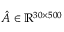Convert formula to latex. <formula><loc_0><loc_0><loc_500><loc_500>\hat { A } \in \mathbb { R } ^ { 3 0 \times 5 0 0 }</formula> 